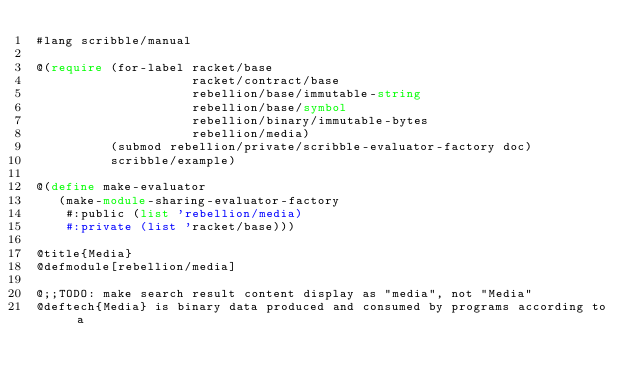<code> <loc_0><loc_0><loc_500><loc_500><_Racket_>#lang scribble/manual

@(require (for-label racket/base
                     racket/contract/base
                     rebellion/base/immutable-string
                     rebellion/base/symbol
                     rebellion/binary/immutable-bytes
                     rebellion/media)
          (submod rebellion/private/scribble-evaluator-factory doc)
          scribble/example)

@(define make-evaluator
   (make-module-sharing-evaluator-factory
    #:public (list 'rebellion/media)
    #:private (list 'racket/base)))

@title{Media}
@defmodule[rebellion/media]

@;;TODO: make search result content display as "media", not "Media"
@deftech{Media} is binary data produced and consumed by programs according to a</code> 